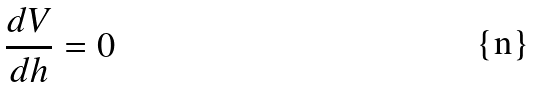Convert formula to latex. <formula><loc_0><loc_0><loc_500><loc_500>\frac { d V } { d h } = 0</formula> 